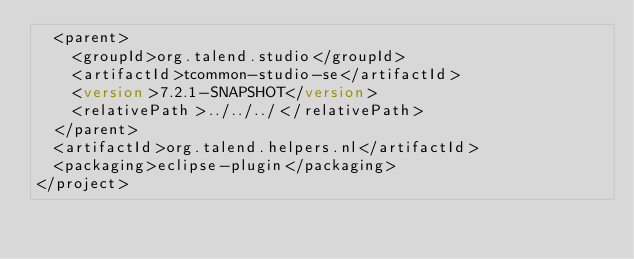<code> <loc_0><loc_0><loc_500><loc_500><_XML_>  <parent>
    <groupId>org.talend.studio</groupId>
    <artifactId>tcommon-studio-se</artifactId>
    <version>7.2.1-SNAPSHOT</version>
    <relativePath>../../../</relativePath>
  </parent>
  <artifactId>org.talend.helpers.nl</artifactId>
  <packaging>eclipse-plugin</packaging>
</project>
</code> 